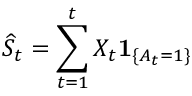<formula> <loc_0><loc_0><loc_500><loc_500>\widehat { S } _ { t } = \sum _ { t = 1 } ^ { t } X _ { t } 1 _ { \{ A _ { t } = 1 \} }</formula> 